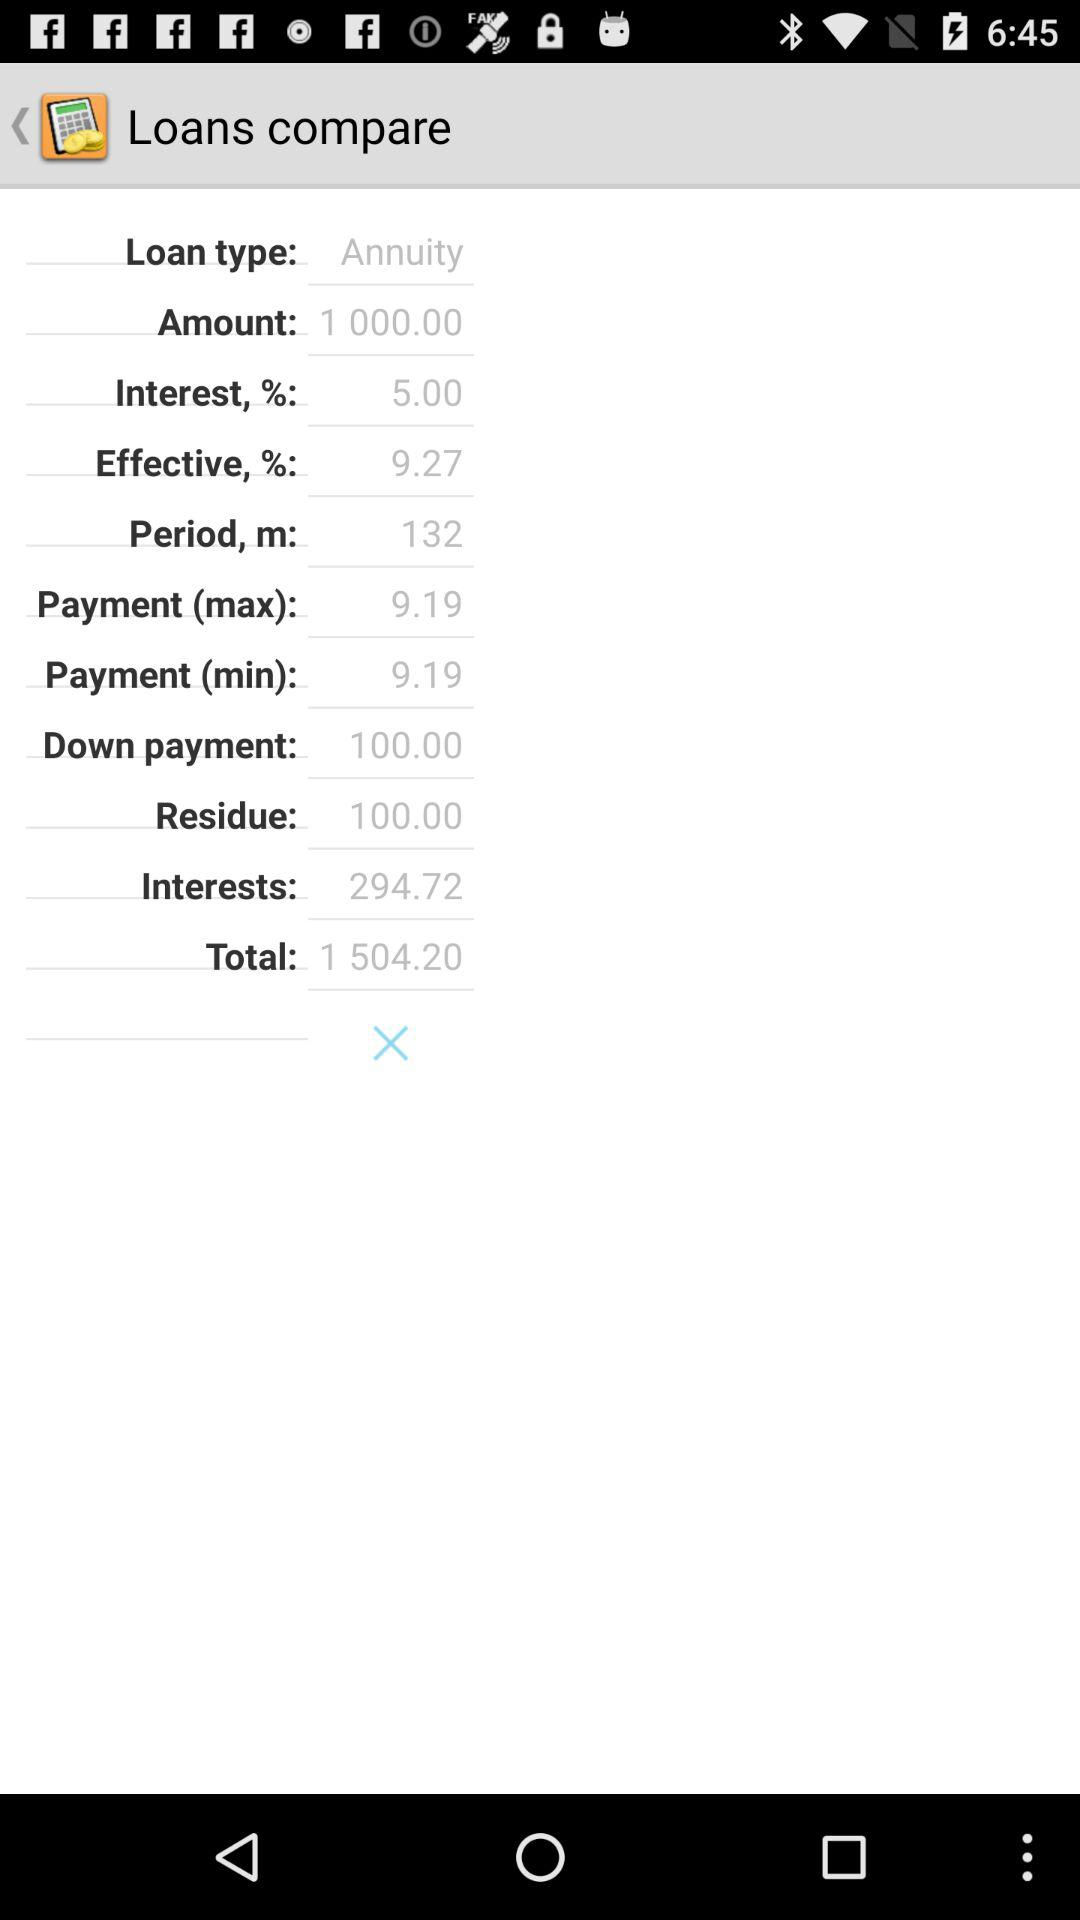What is the effective percentage? The effective percentage is 9.27. 